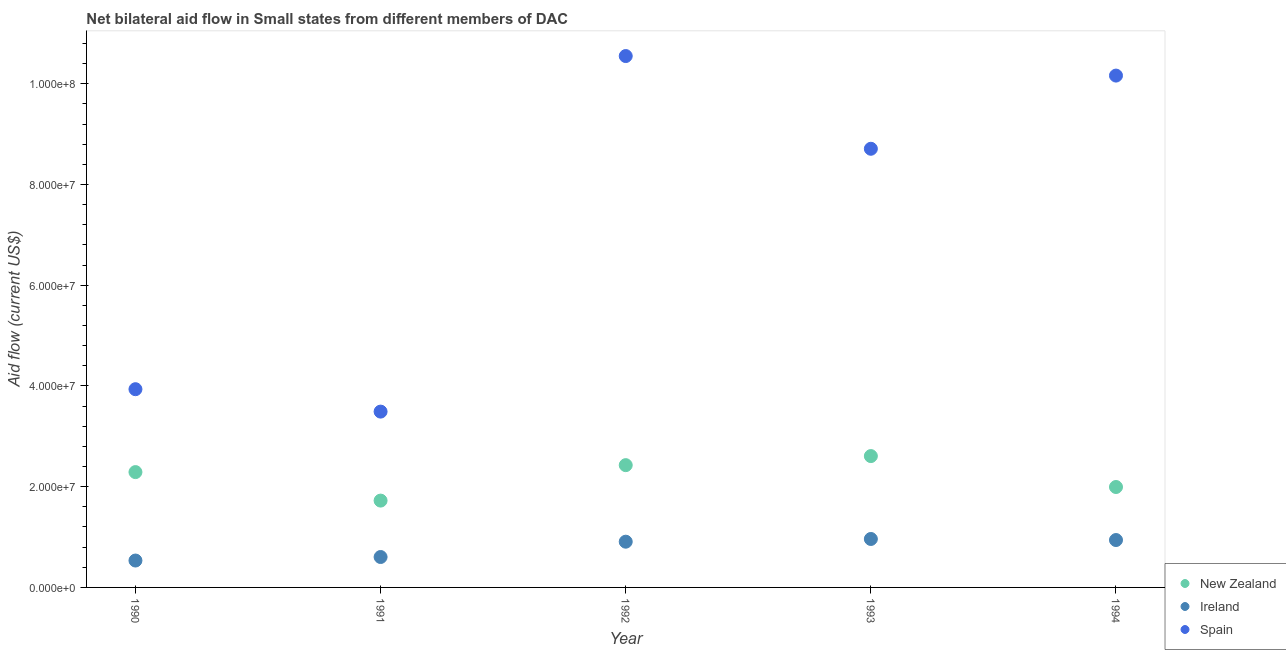How many different coloured dotlines are there?
Offer a very short reply. 3. What is the amount of aid provided by spain in 1993?
Give a very brief answer. 8.71e+07. Across all years, what is the maximum amount of aid provided by new zealand?
Provide a succinct answer. 2.61e+07. Across all years, what is the minimum amount of aid provided by ireland?
Provide a succinct answer. 5.34e+06. In which year was the amount of aid provided by ireland minimum?
Offer a terse response. 1990. What is the total amount of aid provided by ireland in the graph?
Offer a very short reply. 3.95e+07. What is the difference between the amount of aid provided by spain in 1990 and that in 1991?
Provide a short and direct response. 4.45e+06. What is the difference between the amount of aid provided by new zealand in 1994 and the amount of aid provided by spain in 1991?
Keep it short and to the point. -1.50e+07. What is the average amount of aid provided by spain per year?
Your answer should be compact. 7.37e+07. In the year 1991, what is the difference between the amount of aid provided by spain and amount of aid provided by new zealand?
Provide a short and direct response. 1.77e+07. In how many years, is the amount of aid provided by new zealand greater than 104000000 US$?
Your answer should be compact. 0. What is the ratio of the amount of aid provided by spain in 1993 to that in 1994?
Your answer should be compact. 0.86. What is the difference between the highest and the second highest amount of aid provided by spain?
Your answer should be very brief. 3.88e+06. What is the difference between the highest and the lowest amount of aid provided by spain?
Your answer should be very brief. 7.06e+07. In how many years, is the amount of aid provided by spain greater than the average amount of aid provided by spain taken over all years?
Make the answer very short. 3. Is the sum of the amount of aid provided by new zealand in 1991 and 1994 greater than the maximum amount of aid provided by spain across all years?
Provide a short and direct response. No. Does the amount of aid provided by new zealand monotonically increase over the years?
Give a very brief answer. No. Is the amount of aid provided by spain strictly greater than the amount of aid provided by new zealand over the years?
Ensure brevity in your answer.  Yes. Is the amount of aid provided by new zealand strictly less than the amount of aid provided by ireland over the years?
Your response must be concise. No. Does the graph contain grids?
Keep it short and to the point. No. How many legend labels are there?
Provide a succinct answer. 3. What is the title of the graph?
Keep it short and to the point. Net bilateral aid flow in Small states from different members of DAC. What is the label or title of the X-axis?
Your response must be concise. Year. What is the Aid flow (current US$) of New Zealand in 1990?
Offer a terse response. 2.29e+07. What is the Aid flow (current US$) of Ireland in 1990?
Your answer should be very brief. 5.34e+06. What is the Aid flow (current US$) of Spain in 1990?
Your answer should be very brief. 3.94e+07. What is the Aid flow (current US$) in New Zealand in 1991?
Give a very brief answer. 1.72e+07. What is the Aid flow (current US$) of Ireland in 1991?
Your response must be concise. 6.04e+06. What is the Aid flow (current US$) of Spain in 1991?
Give a very brief answer. 3.49e+07. What is the Aid flow (current US$) of New Zealand in 1992?
Your answer should be very brief. 2.43e+07. What is the Aid flow (current US$) in Ireland in 1992?
Provide a short and direct response. 9.08e+06. What is the Aid flow (current US$) of Spain in 1992?
Your answer should be very brief. 1.06e+08. What is the Aid flow (current US$) of New Zealand in 1993?
Your response must be concise. 2.61e+07. What is the Aid flow (current US$) of Ireland in 1993?
Provide a succinct answer. 9.62e+06. What is the Aid flow (current US$) in Spain in 1993?
Offer a very short reply. 8.71e+07. What is the Aid flow (current US$) in New Zealand in 1994?
Ensure brevity in your answer.  1.99e+07. What is the Aid flow (current US$) in Ireland in 1994?
Provide a succinct answer. 9.41e+06. What is the Aid flow (current US$) in Spain in 1994?
Provide a succinct answer. 1.02e+08. Across all years, what is the maximum Aid flow (current US$) in New Zealand?
Give a very brief answer. 2.61e+07. Across all years, what is the maximum Aid flow (current US$) in Ireland?
Keep it short and to the point. 9.62e+06. Across all years, what is the maximum Aid flow (current US$) of Spain?
Make the answer very short. 1.06e+08. Across all years, what is the minimum Aid flow (current US$) in New Zealand?
Make the answer very short. 1.72e+07. Across all years, what is the minimum Aid flow (current US$) in Ireland?
Provide a short and direct response. 5.34e+06. Across all years, what is the minimum Aid flow (current US$) in Spain?
Keep it short and to the point. 3.49e+07. What is the total Aid flow (current US$) of New Zealand in the graph?
Make the answer very short. 1.10e+08. What is the total Aid flow (current US$) of Ireland in the graph?
Offer a terse response. 3.95e+07. What is the total Aid flow (current US$) in Spain in the graph?
Make the answer very short. 3.69e+08. What is the difference between the Aid flow (current US$) in New Zealand in 1990 and that in 1991?
Your answer should be compact. 5.66e+06. What is the difference between the Aid flow (current US$) of Ireland in 1990 and that in 1991?
Your answer should be compact. -7.00e+05. What is the difference between the Aid flow (current US$) of Spain in 1990 and that in 1991?
Keep it short and to the point. 4.45e+06. What is the difference between the Aid flow (current US$) in New Zealand in 1990 and that in 1992?
Ensure brevity in your answer.  -1.38e+06. What is the difference between the Aid flow (current US$) of Ireland in 1990 and that in 1992?
Offer a terse response. -3.74e+06. What is the difference between the Aid flow (current US$) in Spain in 1990 and that in 1992?
Provide a succinct answer. -6.62e+07. What is the difference between the Aid flow (current US$) in New Zealand in 1990 and that in 1993?
Your response must be concise. -3.18e+06. What is the difference between the Aid flow (current US$) of Ireland in 1990 and that in 1993?
Your response must be concise. -4.28e+06. What is the difference between the Aid flow (current US$) in Spain in 1990 and that in 1993?
Provide a short and direct response. -4.77e+07. What is the difference between the Aid flow (current US$) of New Zealand in 1990 and that in 1994?
Your answer should be very brief. 2.96e+06. What is the difference between the Aid flow (current US$) in Ireland in 1990 and that in 1994?
Make the answer very short. -4.07e+06. What is the difference between the Aid flow (current US$) of Spain in 1990 and that in 1994?
Offer a terse response. -6.23e+07. What is the difference between the Aid flow (current US$) of New Zealand in 1991 and that in 1992?
Your response must be concise. -7.04e+06. What is the difference between the Aid flow (current US$) of Ireland in 1991 and that in 1992?
Keep it short and to the point. -3.04e+06. What is the difference between the Aid flow (current US$) of Spain in 1991 and that in 1992?
Offer a very short reply. -7.06e+07. What is the difference between the Aid flow (current US$) in New Zealand in 1991 and that in 1993?
Offer a terse response. -8.84e+06. What is the difference between the Aid flow (current US$) of Ireland in 1991 and that in 1993?
Your response must be concise. -3.58e+06. What is the difference between the Aid flow (current US$) in Spain in 1991 and that in 1993?
Your response must be concise. -5.22e+07. What is the difference between the Aid flow (current US$) of New Zealand in 1991 and that in 1994?
Keep it short and to the point. -2.70e+06. What is the difference between the Aid flow (current US$) in Ireland in 1991 and that in 1994?
Your answer should be very brief. -3.37e+06. What is the difference between the Aid flow (current US$) in Spain in 1991 and that in 1994?
Provide a short and direct response. -6.67e+07. What is the difference between the Aid flow (current US$) of New Zealand in 1992 and that in 1993?
Keep it short and to the point. -1.80e+06. What is the difference between the Aid flow (current US$) in Ireland in 1992 and that in 1993?
Give a very brief answer. -5.40e+05. What is the difference between the Aid flow (current US$) of Spain in 1992 and that in 1993?
Offer a very short reply. 1.84e+07. What is the difference between the Aid flow (current US$) in New Zealand in 1992 and that in 1994?
Give a very brief answer. 4.34e+06. What is the difference between the Aid flow (current US$) of Ireland in 1992 and that in 1994?
Give a very brief answer. -3.30e+05. What is the difference between the Aid flow (current US$) of Spain in 1992 and that in 1994?
Make the answer very short. 3.88e+06. What is the difference between the Aid flow (current US$) in New Zealand in 1993 and that in 1994?
Provide a short and direct response. 6.14e+06. What is the difference between the Aid flow (current US$) of Ireland in 1993 and that in 1994?
Keep it short and to the point. 2.10e+05. What is the difference between the Aid flow (current US$) in Spain in 1993 and that in 1994?
Provide a succinct answer. -1.45e+07. What is the difference between the Aid flow (current US$) of New Zealand in 1990 and the Aid flow (current US$) of Ireland in 1991?
Give a very brief answer. 1.69e+07. What is the difference between the Aid flow (current US$) in New Zealand in 1990 and the Aid flow (current US$) in Spain in 1991?
Make the answer very short. -1.20e+07. What is the difference between the Aid flow (current US$) of Ireland in 1990 and the Aid flow (current US$) of Spain in 1991?
Ensure brevity in your answer.  -2.96e+07. What is the difference between the Aid flow (current US$) in New Zealand in 1990 and the Aid flow (current US$) in Ireland in 1992?
Provide a succinct answer. 1.38e+07. What is the difference between the Aid flow (current US$) of New Zealand in 1990 and the Aid flow (current US$) of Spain in 1992?
Your answer should be very brief. -8.26e+07. What is the difference between the Aid flow (current US$) in Ireland in 1990 and the Aid flow (current US$) in Spain in 1992?
Keep it short and to the point. -1.00e+08. What is the difference between the Aid flow (current US$) of New Zealand in 1990 and the Aid flow (current US$) of Ireland in 1993?
Provide a succinct answer. 1.33e+07. What is the difference between the Aid flow (current US$) of New Zealand in 1990 and the Aid flow (current US$) of Spain in 1993?
Offer a terse response. -6.42e+07. What is the difference between the Aid flow (current US$) of Ireland in 1990 and the Aid flow (current US$) of Spain in 1993?
Provide a succinct answer. -8.18e+07. What is the difference between the Aid flow (current US$) in New Zealand in 1990 and the Aid flow (current US$) in Ireland in 1994?
Ensure brevity in your answer.  1.35e+07. What is the difference between the Aid flow (current US$) of New Zealand in 1990 and the Aid flow (current US$) of Spain in 1994?
Offer a terse response. -7.87e+07. What is the difference between the Aid flow (current US$) in Ireland in 1990 and the Aid flow (current US$) in Spain in 1994?
Offer a very short reply. -9.63e+07. What is the difference between the Aid flow (current US$) in New Zealand in 1991 and the Aid flow (current US$) in Ireland in 1992?
Ensure brevity in your answer.  8.16e+06. What is the difference between the Aid flow (current US$) in New Zealand in 1991 and the Aid flow (current US$) in Spain in 1992?
Provide a short and direct response. -8.83e+07. What is the difference between the Aid flow (current US$) in Ireland in 1991 and the Aid flow (current US$) in Spain in 1992?
Provide a succinct answer. -9.95e+07. What is the difference between the Aid flow (current US$) in New Zealand in 1991 and the Aid flow (current US$) in Ireland in 1993?
Your response must be concise. 7.62e+06. What is the difference between the Aid flow (current US$) in New Zealand in 1991 and the Aid flow (current US$) in Spain in 1993?
Keep it short and to the point. -6.99e+07. What is the difference between the Aid flow (current US$) in Ireland in 1991 and the Aid flow (current US$) in Spain in 1993?
Give a very brief answer. -8.11e+07. What is the difference between the Aid flow (current US$) in New Zealand in 1991 and the Aid flow (current US$) in Ireland in 1994?
Make the answer very short. 7.83e+06. What is the difference between the Aid flow (current US$) in New Zealand in 1991 and the Aid flow (current US$) in Spain in 1994?
Ensure brevity in your answer.  -8.44e+07. What is the difference between the Aid flow (current US$) of Ireland in 1991 and the Aid flow (current US$) of Spain in 1994?
Your response must be concise. -9.56e+07. What is the difference between the Aid flow (current US$) in New Zealand in 1992 and the Aid flow (current US$) in Ireland in 1993?
Your response must be concise. 1.47e+07. What is the difference between the Aid flow (current US$) of New Zealand in 1992 and the Aid flow (current US$) of Spain in 1993?
Give a very brief answer. -6.28e+07. What is the difference between the Aid flow (current US$) in Ireland in 1992 and the Aid flow (current US$) in Spain in 1993?
Your answer should be very brief. -7.80e+07. What is the difference between the Aid flow (current US$) of New Zealand in 1992 and the Aid flow (current US$) of Ireland in 1994?
Make the answer very short. 1.49e+07. What is the difference between the Aid flow (current US$) in New Zealand in 1992 and the Aid flow (current US$) in Spain in 1994?
Offer a terse response. -7.74e+07. What is the difference between the Aid flow (current US$) in Ireland in 1992 and the Aid flow (current US$) in Spain in 1994?
Make the answer very short. -9.26e+07. What is the difference between the Aid flow (current US$) of New Zealand in 1993 and the Aid flow (current US$) of Ireland in 1994?
Your response must be concise. 1.67e+07. What is the difference between the Aid flow (current US$) in New Zealand in 1993 and the Aid flow (current US$) in Spain in 1994?
Your answer should be very brief. -7.56e+07. What is the difference between the Aid flow (current US$) of Ireland in 1993 and the Aid flow (current US$) of Spain in 1994?
Your answer should be very brief. -9.20e+07. What is the average Aid flow (current US$) in New Zealand per year?
Offer a very short reply. 2.21e+07. What is the average Aid flow (current US$) of Ireland per year?
Offer a terse response. 7.90e+06. What is the average Aid flow (current US$) of Spain per year?
Offer a very short reply. 7.37e+07. In the year 1990, what is the difference between the Aid flow (current US$) of New Zealand and Aid flow (current US$) of Ireland?
Your answer should be very brief. 1.76e+07. In the year 1990, what is the difference between the Aid flow (current US$) of New Zealand and Aid flow (current US$) of Spain?
Give a very brief answer. -1.65e+07. In the year 1990, what is the difference between the Aid flow (current US$) of Ireland and Aid flow (current US$) of Spain?
Provide a short and direct response. -3.40e+07. In the year 1991, what is the difference between the Aid flow (current US$) of New Zealand and Aid flow (current US$) of Ireland?
Keep it short and to the point. 1.12e+07. In the year 1991, what is the difference between the Aid flow (current US$) in New Zealand and Aid flow (current US$) in Spain?
Provide a succinct answer. -1.77e+07. In the year 1991, what is the difference between the Aid flow (current US$) of Ireland and Aid flow (current US$) of Spain?
Your answer should be very brief. -2.89e+07. In the year 1992, what is the difference between the Aid flow (current US$) of New Zealand and Aid flow (current US$) of Ireland?
Keep it short and to the point. 1.52e+07. In the year 1992, what is the difference between the Aid flow (current US$) of New Zealand and Aid flow (current US$) of Spain?
Your answer should be very brief. -8.12e+07. In the year 1992, what is the difference between the Aid flow (current US$) in Ireland and Aid flow (current US$) in Spain?
Give a very brief answer. -9.64e+07. In the year 1993, what is the difference between the Aid flow (current US$) of New Zealand and Aid flow (current US$) of Ireland?
Your response must be concise. 1.65e+07. In the year 1993, what is the difference between the Aid flow (current US$) of New Zealand and Aid flow (current US$) of Spain?
Ensure brevity in your answer.  -6.10e+07. In the year 1993, what is the difference between the Aid flow (current US$) in Ireland and Aid flow (current US$) in Spain?
Your answer should be very brief. -7.75e+07. In the year 1994, what is the difference between the Aid flow (current US$) in New Zealand and Aid flow (current US$) in Ireland?
Your answer should be compact. 1.05e+07. In the year 1994, what is the difference between the Aid flow (current US$) in New Zealand and Aid flow (current US$) in Spain?
Your response must be concise. -8.17e+07. In the year 1994, what is the difference between the Aid flow (current US$) in Ireland and Aid flow (current US$) in Spain?
Make the answer very short. -9.22e+07. What is the ratio of the Aid flow (current US$) of New Zealand in 1990 to that in 1991?
Offer a very short reply. 1.33. What is the ratio of the Aid flow (current US$) in Ireland in 1990 to that in 1991?
Provide a short and direct response. 0.88. What is the ratio of the Aid flow (current US$) in Spain in 1990 to that in 1991?
Your response must be concise. 1.13. What is the ratio of the Aid flow (current US$) of New Zealand in 1990 to that in 1992?
Provide a succinct answer. 0.94. What is the ratio of the Aid flow (current US$) in Ireland in 1990 to that in 1992?
Provide a short and direct response. 0.59. What is the ratio of the Aid flow (current US$) of Spain in 1990 to that in 1992?
Offer a terse response. 0.37. What is the ratio of the Aid flow (current US$) of New Zealand in 1990 to that in 1993?
Your answer should be compact. 0.88. What is the ratio of the Aid flow (current US$) of Ireland in 1990 to that in 1993?
Provide a short and direct response. 0.56. What is the ratio of the Aid flow (current US$) in Spain in 1990 to that in 1993?
Offer a very short reply. 0.45. What is the ratio of the Aid flow (current US$) of New Zealand in 1990 to that in 1994?
Ensure brevity in your answer.  1.15. What is the ratio of the Aid flow (current US$) of Ireland in 1990 to that in 1994?
Provide a succinct answer. 0.57. What is the ratio of the Aid flow (current US$) of Spain in 1990 to that in 1994?
Your answer should be compact. 0.39. What is the ratio of the Aid flow (current US$) in New Zealand in 1991 to that in 1992?
Provide a succinct answer. 0.71. What is the ratio of the Aid flow (current US$) of Ireland in 1991 to that in 1992?
Your answer should be compact. 0.67. What is the ratio of the Aid flow (current US$) in Spain in 1991 to that in 1992?
Offer a very short reply. 0.33. What is the ratio of the Aid flow (current US$) of New Zealand in 1991 to that in 1993?
Your response must be concise. 0.66. What is the ratio of the Aid flow (current US$) in Ireland in 1991 to that in 1993?
Your answer should be very brief. 0.63. What is the ratio of the Aid flow (current US$) in Spain in 1991 to that in 1993?
Your answer should be compact. 0.4. What is the ratio of the Aid flow (current US$) of New Zealand in 1991 to that in 1994?
Ensure brevity in your answer.  0.86. What is the ratio of the Aid flow (current US$) in Ireland in 1991 to that in 1994?
Provide a succinct answer. 0.64. What is the ratio of the Aid flow (current US$) of Spain in 1991 to that in 1994?
Provide a short and direct response. 0.34. What is the ratio of the Aid flow (current US$) of New Zealand in 1992 to that in 1993?
Provide a short and direct response. 0.93. What is the ratio of the Aid flow (current US$) of Ireland in 1992 to that in 1993?
Your response must be concise. 0.94. What is the ratio of the Aid flow (current US$) in Spain in 1992 to that in 1993?
Provide a short and direct response. 1.21. What is the ratio of the Aid flow (current US$) of New Zealand in 1992 to that in 1994?
Provide a succinct answer. 1.22. What is the ratio of the Aid flow (current US$) of Ireland in 1992 to that in 1994?
Your answer should be very brief. 0.96. What is the ratio of the Aid flow (current US$) of Spain in 1992 to that in 1994?
Ensure brevity in your answer.  1.04. What is the ratio of the Aid flow (current US$) in New Zealand in 1993 to that in 1994?
Provide a succinct answer. 1.31. What is the ratio of the Aid flow (current US$) of Ireland in 1993 to that in 1994?
Provide a short and direct response. 1.02. What is the ratio of the Aid flow (current US$) of Spain in 1993 to that in 1994?
Ensure brevity in your answer.  0.86. What is the difference between the highest and the second highest Aid flow (current US$) of New Zealand?
Your response must be concise. 1.80e+06. What is the difference between the highest and the second highest Aid flow (current US$) of Ireland?
Make the answer very short. 2.10e+05. What is the difference between the highest and the second highest Aid flow (current US$) in Spain?
Your response must be concise. 3.88e+06. What is the difference between the highest and the lowest Aid flow (current US$) in New Zealand?
Your answer should be compact. 8.84e+06. What is the difference between the highest and the lowest Aid flow (current US$) of Ireland?
Provide a short and direct response. 4.28e+06. What is the difference between the highest and the lowest Aid flow (current US$) of Spain?
Give a very brief answer. 7.06e+07. 